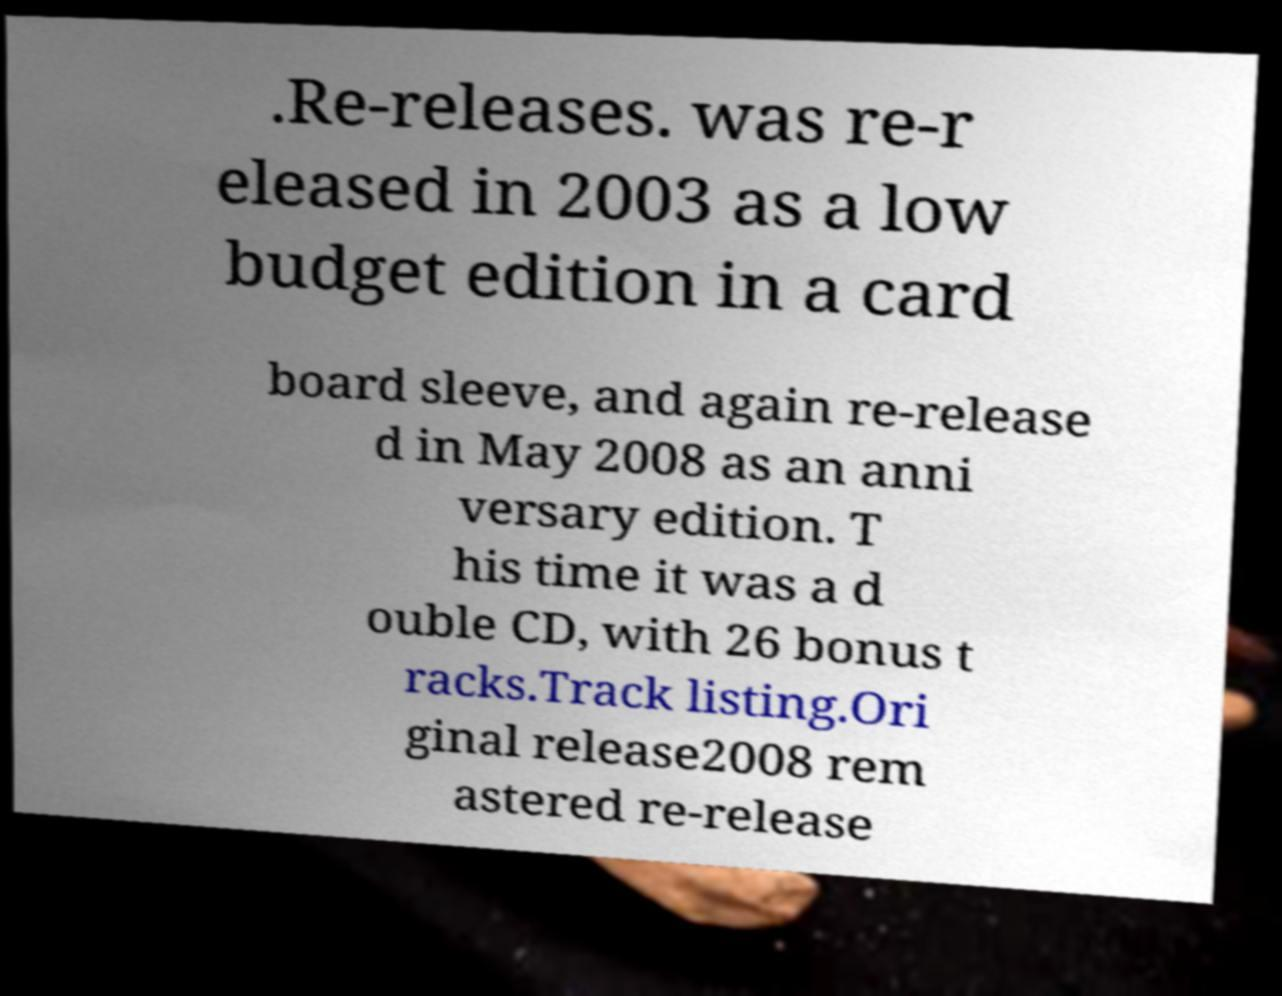Please identify and transcribe the text found in this image. .Re-releases. was re-r eleased in 2003 as a low budget edition in a card board sleeve, and again re-release d in May 2008 as an anni versary edition. T his time it was a d ouble CD, with 26 bonus t racks.Track listing.Ori ginal release2008 rem astered re-release 